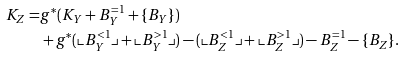Convert formula to latex. <formula><loc_0><loc_0><loc_500><loc_500>K _ { Z } = & g ^ { * } ( K _ { Y } + B ^ { = 1 } _ { Y } + \{ B _ { Y } \} ) \\ & + g ^ { * } ( \llcorner B ^ { < 1 } _ { Y } \lrcorner + \llcorner B ^ { > 1 } _ { Y } \lrcorner ) - ( \llcorner B ^ { < 1 } _ { Z } \lrcorner + \llcorner B ^ { > 1 } _ { Z } \lrcorner ) - B ^ { = 1 } _ { Z } - \{ B _ { Z } \} .</formula> 